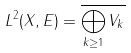Convert formula to latex. <formula><loc_0><loc_0><loc_500><loc_500>L ^ { 2 } ( X , E ) = \overline { \bigoplus _ { k \geq 1 } V _ { k } }</formula> 